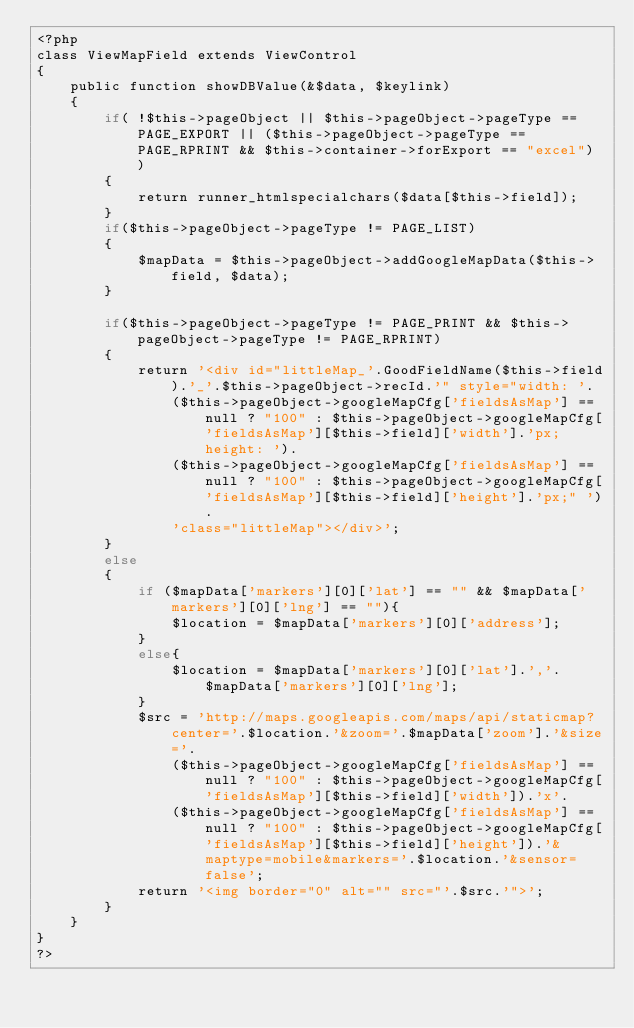Convert code to text. <code><loc_0><loc_0><loc_500><loc_500><_PHP_><?php
class ViewMapField extends ViewControl
{
	public function showDBValue(&$data, $keylink)
	{
		if( !$this->pageObject || $this->pageObject->pageType == PAGE_EXPORT || ($this->pageObject->pageType == PAGE_RPRINT && $this->container->forExport == "excel") ) 
		{
			return runner_htmlspecialchars($data[$this->field]);
 		}
		if($this->pageObject->pageType != PAGE_LIST)
		{
			$mapData = $this->pageObject->addGoogleMapData($this->field, $data);
		}
	
		if($this->pageObject->pageType != PAGE_PRINT && $this->pageObject->pageType != PAGE_RPRINT)
		{	
			return '<div id="littleMap_'.GoodFieldName($this->field).'_'.$this->pageObject->recId.'" style="width: '.
				($this->pageObject->googleMapCfg['fieldsAsMap'] == null ? "100" : $this->pageObject->googleMapCfg['fieldsAsMap'][$this->field]['width'].'px; height: ').
				($this->pageObject->googleMapCfg['fieldsAsMap'] == null ? "100" : $this->pageObject->googleMapCfg['fieldsAsMap'][$this->field]['height'].'px;" ').
				'class="littleMap"></div>';
		}
		else 
		{
			if ($mapData['markers'][0]['lat'] == "" && $mapData['markers'][0]['lng'] == ""){
				$location = $mapData['markers'][0]['address'];
			}
			else{
				$location = $mapData['markers'][0]['lat'].','.$mapData['markers'][0]['lng'];
			}
			$src = 'http://maps.googleapis.com/maps/api/staticmap?center='.$location.'&zoom='.$mapData['zoom'].'&size='.
				($this->pageObject->googleMapCfg['fieldsAsMap'] == null ? "100" : $this->pageObject->googleMapCfg['fieldsAsMap'][$this->field]['width']).'x'.
				($this->pageObject->googleMapCfg['fieldsAsMap'] == null ? "100" : $this->pageObject->googleMapCfg['fieldsAsMap'][$this->field]['height']).'&maptype=mobile&markers='.$location.'&sensor=false';
			return '<img border="0" alt="" src="'.$src.'">';
		}
	}
} 
?></code> 